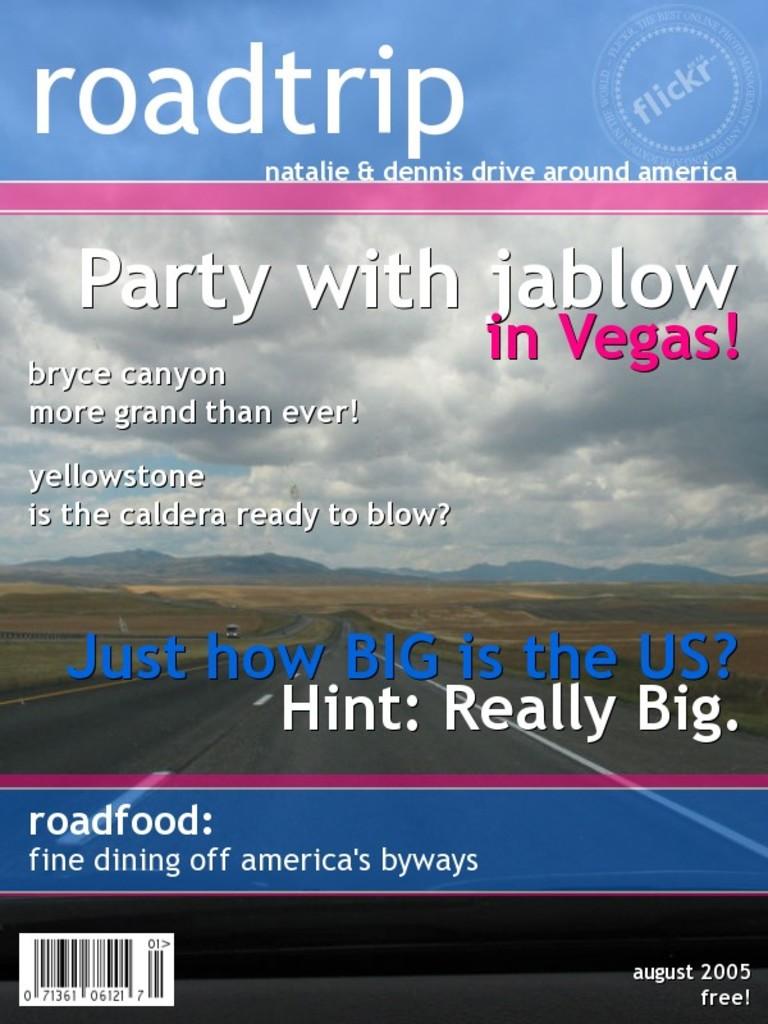Where can you party with jablow?
Give a very brief answer. Vegas. 